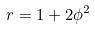<formula> <loc_0><loc_0><loc_500><loc_500>r = 1 + 2 \phi ^ { 2 }</formula> 